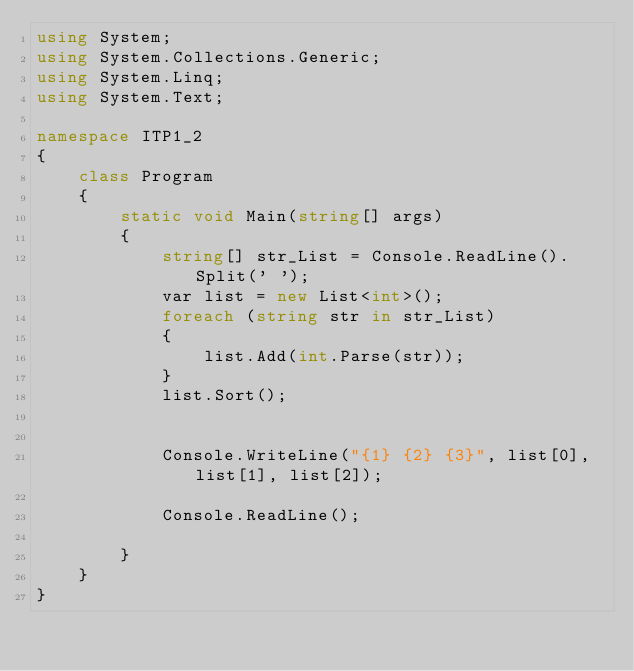Convert code to text. <code><loc_0><loc_0><loc_500><loc_500><_C#_>using System;
using System.Collections.Generic;
using System.Linq;
using System.Text;

namespace ITP1_2
{
    class Program
    {
        static void Main(string[] args)
        {
            string[] str_List = Console.ReadLine().Split(' ');
            var list = new List<int>();
            foreach (string str in str_List)
            {
                list.Add(int.Parse(str));
            }
            list.Sort();


            Console.WriteLine("{1} {2} {3}", list[0], list[1], list[2]);
            
            Console.ReadLine();

        }
    }
}</code> 